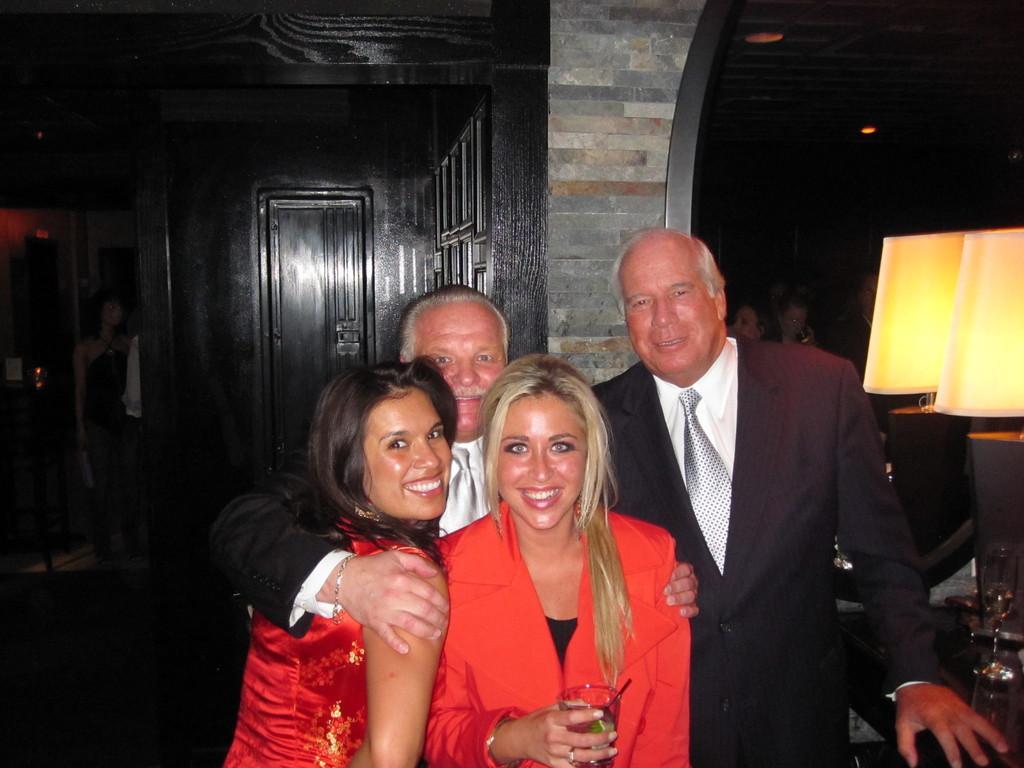Describe this image in one or two sentences. This is an inside view. Here I can see two women and two men are standing, smiling and giving pose for the picture. One woman is holding a glass in the hand. On the right side there are two lamps placed on a table. In the background, I can see some more people and also there is a door to the wall. On the left side there is a person in the dark. 